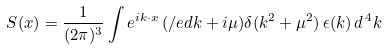<formula> <loc_0><loc_0><loc_500><loc_500>S ( x ) = \frac { 1 } { ( 2 \pi ) ^ { 3 } } \int e ^ { i k \cdot x } \, ( \slash e d { k } + i \mu ) \delta ( k ^ { 2 } + \mu ^ { 2 } ) \, \epsilon ( k ) \, d ^ { \, 4 } k</formula> 